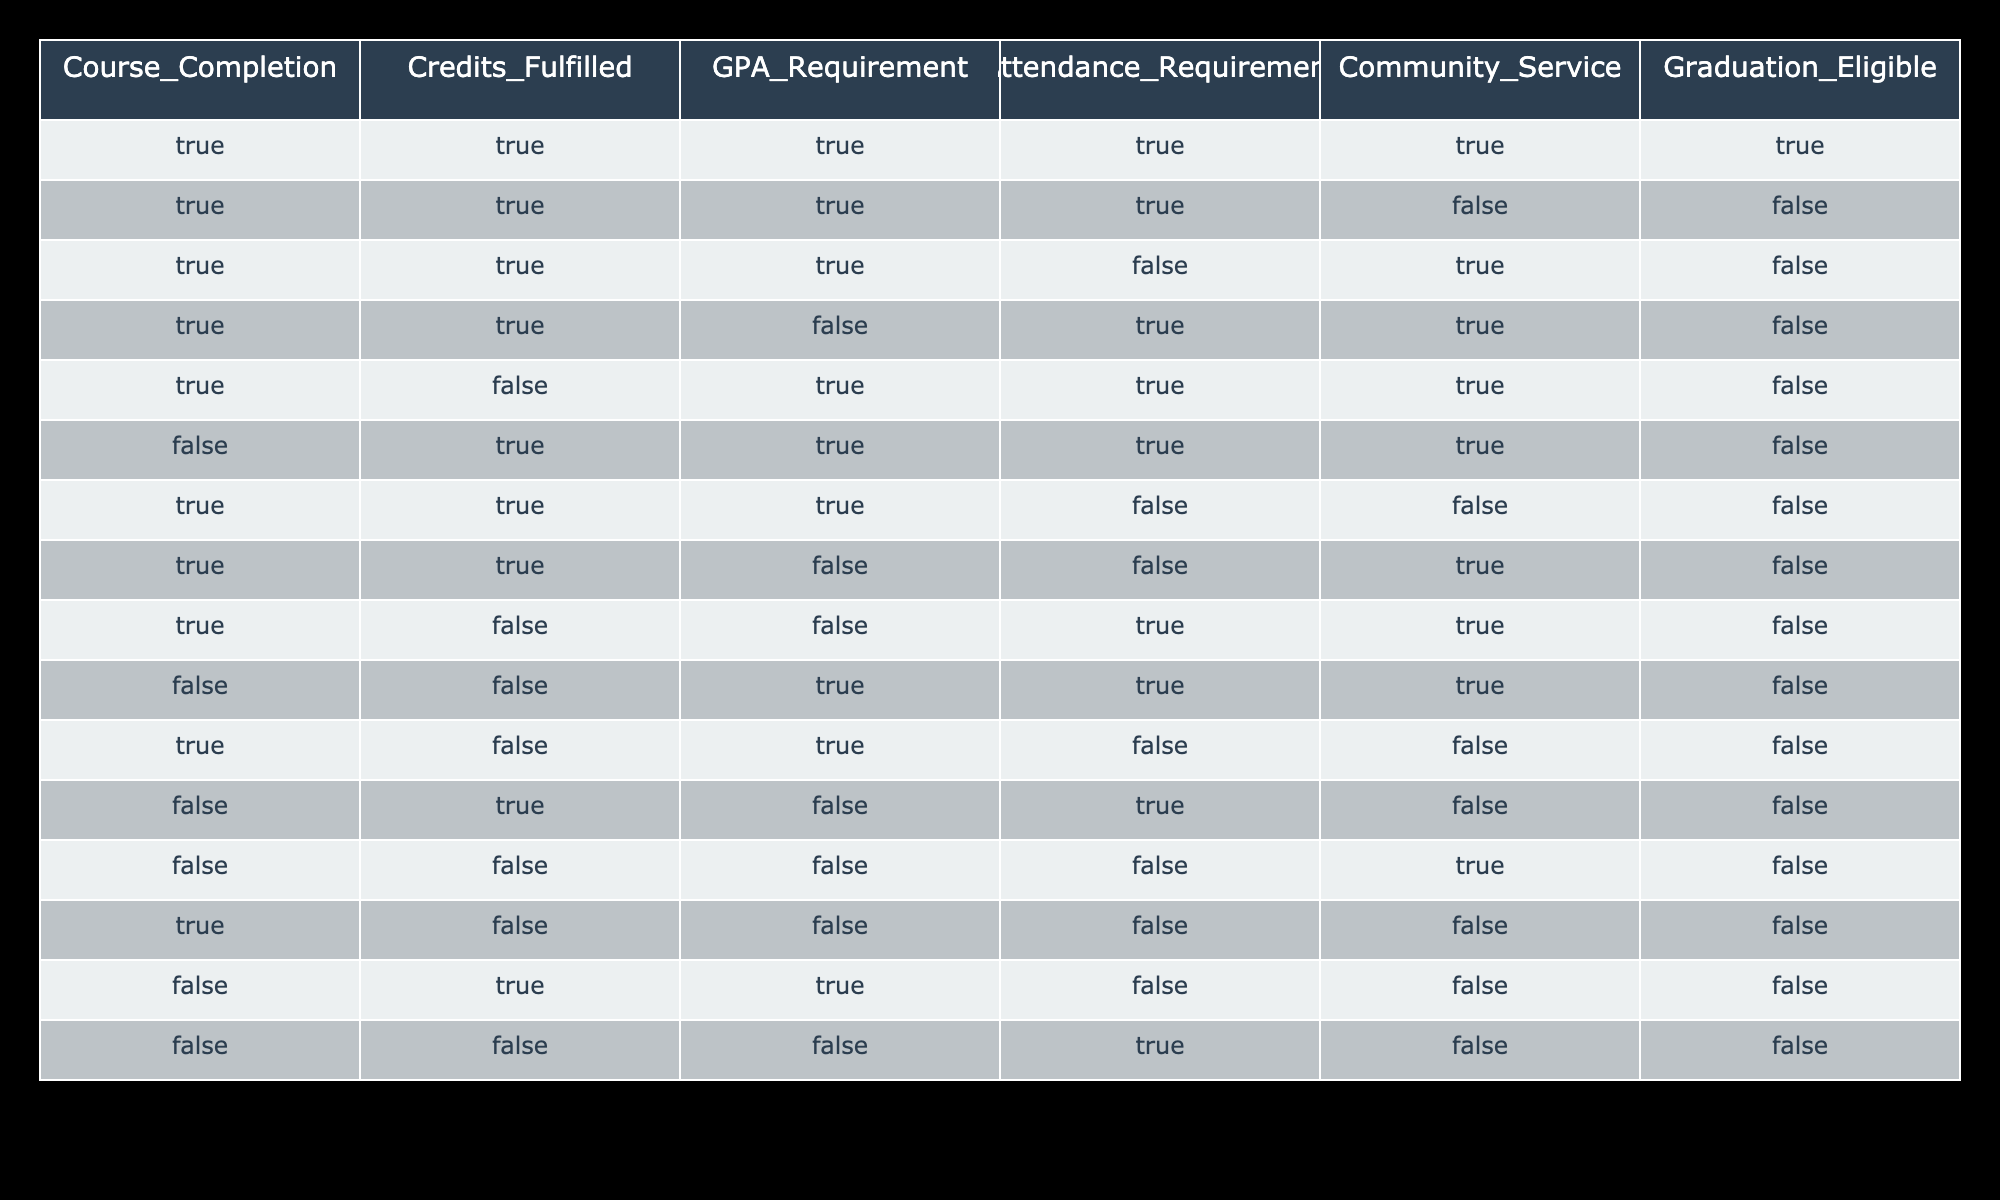What is the total number of cases where graduation eligibility is TRUE? There are 15 rows in the table. Only the first row indicates graduation eligibility is TRUE. The count is 1 for the true condition.
Answer: 1 How many cases have Community Service marked as TRUE? By reviewing the Community Service column, there are 8 instances where it is marked TRUE in the table. Count each occurrence throughout the rows.
Answer: 8 If a student has completed all course requirements, what is the count of those with Community Service marked as FALSE? From the rows where Course Completion is TRUE, we identify those with Community Service marked as FALSE. There are 4 rows fitting this criterion.
Answer: 4 Is it true that a student can be graduation eligible with a FALSE GPA Requirement? There is 1 row where the GPA Requirement is FALSE while Graduation Eligible is TRUE. Therefore, it is true.
Answer: Yes What percentage of students with TRUE Credits Fulfilled are also graduation eligible? There are 8 instances of TRUE in the Credits Fulfilled column. Out of those, 1 row shows graduation eligibility as TRUE. The percentage is (1/8) * 100 = 12.5%.
Answer: 12.5% How many cases have both Attendance Requirement and Community Service as TRUE? Scanning through the table, there are 3 instances where both Attendance Requirement and Community Service are marked TRUE simultaneously.
Answer: 3 What is the average number of requirements fulfilled among those who are graduation eligible? In cases marked TRUE for graduation eligibility, the total satisfied requirement count is 5 (one from each eligible row). The average here from the rows would be 5/1 = 5.
Answer: 5 In how many cases is it false that a student meets all requirements for graduation eligibility? From the table, we find there are 15 cases total. Among those, 14 of them are marked as false. Therefore, there are 14 cases that are marked false concerning graduation requirements.
Answer: 14 Which requirement is most often not met by those who are not graduation eligible? Evaluating the data in cases where graduation eligibility is FALSE reveals that the Attendance Requirement is the one most often not fulfilled, appearing in 10 instances.
Answer: Attendance Requirement 